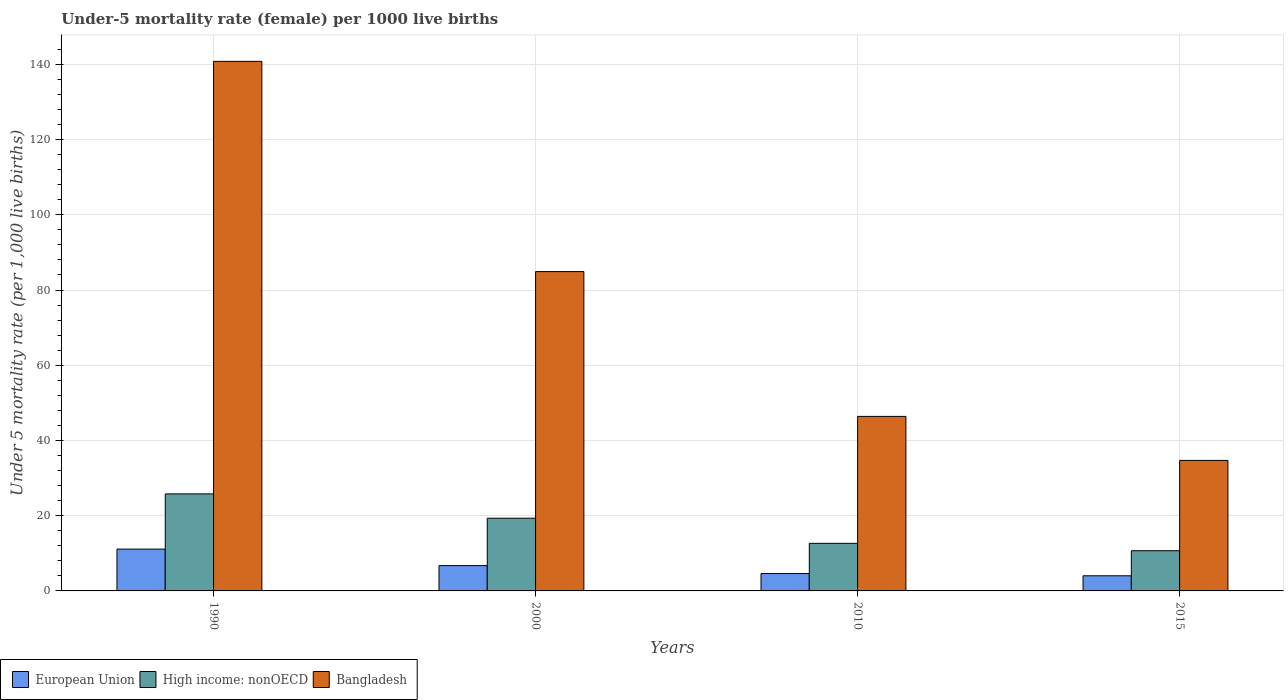Are the number of bars per tick equal to the number of legend labels?
Your answer should be compact. Yes. Are the number of bars on each tick of the X-axis equal?
Ensure brevity in your answer.  Yes. How many bars are there on the 4th tick from the left?
Give a very brief answer. 3. How many bars are there on the 1st tick from the right?
Keep it short and to the point. 3. What is the label of the 4th group of bars from the left?
Keep it short and to the point. 2015. In how many cases, is the number of bars for a given year not equal to the number of legend labels?
Keep it short and to the point. 0. What is the under-five mortality rate in High income: nonOECD in 2010?
Give a very brief answer. 12.65. Across all years, what is the maximum under-five mortality rate in Bangladesh?
Your answer should be compact. 140.8. Across all years, what is the minimum under-five mortality rate in Bangladesh?
Provide a short and direct response. 34.7. In which year was the under-five mortality rate in European Union maximum?
Your answer should be very brief. 1990. In which year was the under-five mortality rate in European Union minimum?
Make the answer very short. 2015. What is the total under-five mortality rate in High income: nonOECD in the graph?
Provide a short and direct response. 68.47. What is the difference between the under-five mortality rate in European Union in 2010 and that in 2015?
Your response must be concise. 0.6. What is the difference between the under-five mortality rate in European Union in 2000 and the under-five mortality rate in Bangladesh in 2015?
Provide a short and direct response. -27.97. What is the average under-five mortality rate in Bangladesh per year?
Provide a short and direct response. 76.7. In the year 2000, what is the difference between the under-five mortality rate in High income: nonOECD and under-five mortality rate in European Union?
Keep it short and to the point. 12.6. In how many years, is the under-five mortality rate in High income: nonOECD greater than 80?
Offer a terse response. 0. What is the ratio of the under-five mortality rate in European Union in 2010 to that in 2015?
Keep it short and to the point. 1.15. What is the difference between the highest and the second highest under-five mortality rate in Bangladesh?
Your answer should be very brief. 55.9. What is the difference between the highest and the lowest under-five mortality rate in European Union?
Provide a short and direct response. 7.1. In how many years, is the under-five mortality rate in High income: nonOECD greater than the average under-five mortality rate in High income: nonOECD taken over all years?
Make the answer very short. 2. Is the sum of the under-five mortality rate in European Union in 1990 and 2015 greater than the maximum under-five mortality rate in High income: nonOECD across all years?
Offer a terse response. No. What does the 2nd bar from the left in 2010 represents?
Offer a very short reply. High income: nonOECD. Is it the case that in every year, the sum of the under-five mortality rate in High income: nonOECD and under-five mortality rate in Bangladesh is greater than the under-five mortality rate in European Union?
Offer a terse response. Yes. How many years are there in the graph?
Ensure brevity in your answer.  4. How many legend labels are there?
Provide a succinct answer. 3. How are the legend labels stacked?
Provide a short and direct response. Horizontal. What is the title of the graph?
Offer a very short reply. Under-5 mortality rate (female) per 1000 live births. Does "Central Europe" appear as one of the legend labels in the graph?
Give a very brief answer. No. What is the label or title of the X-axis?
Offer a very short reply. Years. What is the label or title of the Y-axis?
Offer a terse response. Under 5 mortality rate (per 1,0 live births). What is the Under 5 mortality rate (per 1,000 live births) of European Union in 1990?
Offer a very short reply. 11.12. What is the Under 5 mortality rate (per 1,000 live births) of High income: nonOECD in 1990?
Give a very brief answer. 25.8. What is the Under 5 mortality rate (per 1,000 live births) of Bangladesh in 1990?
Give a very brief answer. 140.8. What is the Under 5 mortality rate (per 1,000 live births) in European Union in 2000?
Your response must be concise. 6.73. What is the Under 5 mortality rate (per 1,000 live births) of High income: nonOECD in 2000?
Offer a very short reply. 19.34. What is the Under 5 mortality rate (per 1,000 live births) in Bangladesh in 2000?
Ensure brevity in your answer.  84.9. What is the Under 5 mortality rate (per 1,000 live births) of European Union in 2010?
Your response must be concise. 4.62. What is the Under 5 mortality rate (per 1,000 live births) in High income: nonOECD in 2010?
Your answer should be very brief. 12.65. What is the Under 5 mortality rate (per 1,000 live births) of Bangladesh in 2010?
Ensure brevity in your answer.  46.4. What is the Under 5 mortality rate (per 1,000 live births) of European Union in 2015?
Ensure brevity in your answer.  4.02. What is the Under 5 mortality rate (per 1,000 live births) in High income: nonOECD in 2015?
Keep it short and to the point. 10.69. What is the Under 5 mortality rate (per 1,000 live births) of Bangladesh in 2015?
Provide a succinct answer. 34.7. Across all years, what is the maximum Under 5 mortality rate (per 1,000 live births) in European Union?
Your answer should be compact. 11.12. Across all years, what is the maximum Under 5 mortality rate (per 1,000 live births) in High income: nonOECD?
Offer a terse response. 25.8. Across all years, what is the maximum Under 5 mortality rate (per 1,000 live births) in Bangladesh?
Your answer should be compact. 140.8. Across all years, what is the minimum Under 5 mortality rate (per 1,000 live births) in European Union?
Keep it short and to the point. 4.02. Across all years, what is the minimum Under 5 mortality rate (per 1,000 live births) in High income: nonOECD?
Provide a succinct answer. 10.69. Across all years, what is the minimum Under 5 mortality rate (per 1,000 live births) of Bangladesh?
Offer a very short reply. 34.7. What is the total Under 5 mortality rate (per 1,000 live births) in European Union in the graph?
Your answer should be very brief. 26.5. What is the total Under 5 mortality rate (per 1,000 live births) in High income: nonOECD in the graph?
Your answer should be very brief. 68.47. What is the total Under 5 mortality rate (per 1,000 live births) in Bangladesh in the graph?
Provide a succinct answer. 306.8. What is the difference between the Under 5 mortality rate (per 1,000 live births) of European Union in 1990 and that in 2000?
Your answer should be compact. 4.38. What is the difference between the Under 5 mortality rate (per 1,000 live births) of High income: nonOECD in 1990 and that in 2000?
Offer a very short reply. 6.46. What is the difference between the Under 5 mortality rate (per 1,000 live births) of Bangladesh in 1990 and that in 2000?
Ensure brevity in your answer.  55.9. What is the difference between the Under 5 mortality rate (per 1,000 live births) of European Union in 1990 and that in 2010?
Your response must be concise. 6.49. What is the difference between the Under 5 mortality rate (per 1,000 live births) of High income: nonOECD in 1990 and that in 2010?
Offer a terse response. 13.15. What is the difference between the Under 5 mortality rate (per 1,000 live births) of Bangladesh in 1990 and that in 2010?
Your answer should be compact. 94.4. What is the difference between the Under 5 mortality rate (per 1,000 live births) in European Union in 1990 and that in 2015?
Ensure brevity in your answer.  7.1. What is the difference between the Under 5 mortality rate (per 1,000 live births) in High income: nonOECD in 1990 and that in 2015?
Give a very brief answer. 15.11. What is the difference between the Under 5 mortality rate (per 1,000 live births) of Bangladesh in 1990 and that in 2015?
Offer a terse response. 106.1. What is the difference between the Under 5 mortality rate (per 1,000 live births) in European Union in 2000 and that in 2010?
Give a very brief answer. 2.11. What is the difference between the Under 5 mortality rate (per 1,000 live births) of High income: nonOECD in 2000 and that in 2010?
Make the answer very short. 6.69. What is the difference between the Under 5 mortality rate (per 1,000 live births) of Bangladesh in 2000 and that in 2010?
Keep it short and to the point. 38.5. What is the difference between the Under 5 mortality rate (per 1,000 live births) of European Union in 2000 and that in 2015?
Offer a very short reply. 2.71. What is the difference between the Under 5 mortality rate (per 1,000 live births) in High income: nonOECD in 2000 and that in 2015?
Your answer should be compact. 8.65. What is the difference between the Under 5 mortality rate (per 1,000 live births) of Bangladesh in 2000 and that in 2015?
Your response must be concise. 50.2. What is the difference between the Under 5 mortality rate (per 1,000 live births) of European Union in 2010 and that in 2015?
Your answer should be very brief. 0.6. What is the difference between the Under 5 mortality rate (per 1,000 live births) of High income: nonOECD in 2010 and that in 2015?
Your answer should be compact. 1.96. What is the difference between the Under 5 mortality rate (per 1,000 live births) of Bangladesh in 2010 and that in 2015?
Your response must be concise. 11.7. What is the difference between the Under 5 mortality rate (per 1,000 live births) of European Union in 1990 and the Under 5 mortality rate (per 1,000 live births) of High income: nonOECD in 2000?
Ensure brevity in your answer.  -8.22. What is the difference between the Under 5 mortality rate (per 1,000 live births) in European Union in 1990 and the Under 5 mortality rate (per 1,000 live births) in Bangladesh in 2000?
Your response must be concise. -73.78. What is the difference between the Under 5 mortality rate (per 1,000 live births) of High income: nonOECD in 1990 and the Under 5 mortality rate (per 1,000 live births) of Bangladesh in 2000?
Offer a very short reply. -59.1. What is the difference between the Under 5 mortality rate (per 1,000 live births) in European Union in 1990 and the Under 5 mortality rate (per 1,000 live births) in High income: nonOECD in 2010?
Keep it short and to the point. -1.53. What is the difference between the Under 5 mortality rate (per 1,000 live births) of European Union in 1990 and the Under 5 mortality rate (per 1,000 live births) of Bangladesh in 2010?
Your answer should be compact. -35.28. What is the difference between the Under 5 mortality rate (per 1,000 live births) in High income: nonOECD in 1990 and the Under 5 mortality rate (per 1,000 live births) in Bangladesh in 2010?
Your answer should be very brief. -20.6. What is the difference between the Under 5 mortality rate (per 1,000 live births) of European Union in 1990 and the Under 5 mortality rate (per 1,000 live births) of High income: nonOECD in 2015?
Your response must be concise. 0.43. What is the difference between the Under 5 mortality rate (per 1,000 live births) in European Union in 1990 and the Under 5 mortality rate (per 1,000 live births) in Bangladesh in 2015?
Offer a terse response. -23.58. What is the difference between the Under 5 mortality rate (per 1,000 live births) of High income: nonOECD in 1990 and the Under 5 mortality rate (per 1,000 live births) of Bangladesh in 2015?
Your response must be concise. -8.9. What is the difference between the Under 5 mortality rate (per 1,000 live births) in European Union in 2000 and the Under 5 mortality rate (per 1,000 live births) in High income: nonOECD in 2010?
Give a very brief answer. -5.92. What is the difference between the Under 5 mortality rate (per 1,000 live births) in European Union in 2000 and the Under 5 mortality rate (per 1,000 live births) in Bangladesh in 2010?
Keep it short and to the point. -39.67. What is the difference between the Under 5 mortality rate (per 1,000 live births) in High income: nonOECD in 2000 and the Under 5 mortality rate (per 1,000 live births) in Bangladesh in 2010?
Keep it short and to the point. -27.06. What is the difference between the Under 5 mortality rate (per 1,000 live births) of European Union in 2000 and the Under 5 mortality rate (per 1,000 live births) of High income: nonOECD in 2015?
Provide a short and direct response. -3.95. What is the difference between the Under 5 mortality rate (per 1,000 live births) in European Union in 2000 and the Under 5 mortality rate (per 1,000 live births) in Bangladesh in 2015?
Keep it short and to the point. -27.97. What is the difference between the Under 5 mortality rate (per 1,000 live births) in High income: nonOECD in 2000 and the Under 5 mortality rate (per 1,000 live births) in Bangladesh in 2015?
Your answer should be compact. -15.36. What is the difference between the Under 5 mortality rate (per 1,000 live births) of European Union in 2010 and the Under 5 mortality rate (per 1,000 live births) of High income: nonOECD in 2015?
Your response must be concise. -6.06. What is the difference between the Under 5 mortality rate (per 1,000 live births) in European Union in 2010 and the Under 5 mortality rate (per 1,000 live births) in Bangladesh in 2015?
Your answer should be compact. -30.08. What is the difference between the Under 5 mortality rate (per 1,000 live births) of High income: nonOECD in 2010 and the Under 5 mortality rate (per 1,000 live births) of Bangladesh in 2015?
Offer a terse response. -22.05. What is the average Under 5 mortality rate (per 1,000 live births) of European Union per year?
Your response must be concise. 6.62. What is the average Under 5 mortality rate (per 1,000 live births) in High income: nonOECD per year?
Offer a very short reply. 17.12. What is the average Under 5 mortality rate (per 1,000 live births) in Bangladesh per year?
Provide a succinct answer. 76.7. In the year 1990, what is the difference between the Under 5 mortality rate (per 1,000 live births) of European Union and Under 5 mortality rate (per 1,000 live births) of High income: nonOECD?
Offer a terse response. -14.68. In the year 1990, what is the difference between the Under 5 mortality rate (per 1,000 live births) of European Union and Under 5 mortality rate (per 1,000 live births) of Bangladesh?
Offer a terse response. -129.68. In the year 1990, what is the difference between the Under 5 mortality rate (per 1,000 live births) of High income: nonOECD and Under 5 mortality rate (per 1,000 live births) of Bangladesh?
Your answer should be very brief. -115. In the year 2000, what is the difference between the Under 5 mortality rate (per 1,000 live births) in European Union and Under 5 mortality rate (per 1,000 live births) in High income: nonOECD?
Ensure brevity in your answer.  -12.6. In the year 2000, what is the difference between the Under 5 mortality rate (per 1,000 live births) in European Union and Under 5 mortality rate (per 1,000 live births) in Bangladesh?
Provide a short and direct response. -78.17. In the year 2000, what is the difference between the Under 5 mortality rate (per 1,000 live births) in High income: nonOECD and Under 5 mortality rate (per 1,000 live births) in Bangladesh?
Provide a succinct answer. -65.56. In the year 2010, what is the difference between the Under 5 mortality rate (per 1,000 live births) of European Union and Under 5 mortality rate (per 1,000 live births) of High income: nonOECD?
Offer a terse response. -8.03. In the year 2010, what is the difference between the Under 5 mortality rate (per 1,000 live births) in European Union and Under 5 mortality rate (per 1,000 live births) in Bangladesh?
Offer a very short reply. -41.78. In the year 2010, what is the difference between the Under 5 mortality rate (per 1,000 live births) in High income: nonOECD and Under 5 mortality rate (per 1,000 live births) in Bangladesh?
Provide a succinct answer. -33.75. In the year 2015, what is the difference between the Under 5 mortality rate (per 1,000 live births) of European Union and Under 5 mortality rate (per 1,000 live births) of High income: nonOECD?
Offer a terse response. -6.66. In the year 2015, what is the difference between the Under 5 mortality rate (per 1,000 live births) of European Union and Under 5 mortality rate (per 1,000 live births) of Bangladesh?
Keep it short and to the point. -30.68. In the year 2015, what is the difference between the Under 5 mortality rate (per 1,000 live births) in High income: nonOECD and Under 5 mortality rate (per 1,000 live births) in Bangladesh?
Offer a very short reply. -24.01. What is the ratio of the Under 5 mortality rate (per 1,000 live births) in European Union in 1990 to that in 2000?
Ensure brevity in your answer.  1.65. What is the ratio of the Under 5 mortality rate (per 1,000 live births) of High income: nonOECD in 1990 to that in 2000?
Offer a terse response. 1.33. What is the ratio of the Under 5 mortality rate (per 1,000 live births) of Bangladesh in 1990 to that in 2000?
Your answer should be compact. 1.66. What is the ratio of the Under 5 mortality rate (per 1,000 live births) in European Union in 1990 to that in 2010?
Provide a short and direct response. 2.4. What is the ratio of the Under 5 mortality rate (per 1,000 live births) of High income: nonOECD in 1990 to that in 2010?
Provide a succinct answer. 2.04. What is the ratio of the Under 5 mortality rate (per 1,000 live births) in Bangladesh in 1990 to that in 2010?
Offer a terse response. 3.03. What is the ratio of the Under 5 mortality rate (per 1,000 live births) of European Union in 1990 to that in 2015?
Your answer should be very brief. 2.76. What is the ratio of the Under 5 mortality rate (per 1,000 live births) in High income: nonOECD in 1990 to that in 2015?
Provide a short and direct response. 2.41. What is the ratio of the Under 5 mortality rate (per 1,000 live births) of Bangladesh in 1990 to that in 2015?
Offer a very short reply. 4.06. What is the ratio of the Under 5 mortality rate (per 1,000 live births) in European Union in 2000 to that in 2010?
Keep it short and to the point. 1.46. What is the ratio of the Under 5 mortality rate (per 1,000 live births) in High income: nonOECD in 2000 to that in 2010?
Provide a short and direct response. 1.53. What is the ratio of the Under 5 mortality rate (per 1,000 live births) in Bangladesh in 2000 to that in 2010?
Provide a succinct answer. 1.83. What is the ratio of the Under 5 mortality rate (per 1,000 live births) in European Union in 2000 to that in 2015?
Your answer should be compact. 1.67. What is the ratio of the Under 5 mortality rate (per 1,000 live births) of High income: nonOECD in 2000 to that in 2015?
Make the answer very short. 1.81. What is the ratio of the Under 5 mortality rate (per 1,000 live births) in Bangladesh in 2000 to that in 2015?
Provide a succinct answer. 2.45. What is the ratio of the Under 5 mortality rate (per 1,000 live births) in European Union in 2010 to that in 2015?
Provide a succinct answer. 1.15. What is the ratio of the Under 5 mortality rate (per 1,000 live births) in High income: nonOECD in 2010 to that in 2015?
Ensure brevity in your answer.  1.18. What is the ratio of the Under 5 mortality rate (per 1,000 live births) in Bangladesh in 2010 to that in 2015?
Ensure brevity in your answer.  1.34. What is the difference between the highest and the second highest Under 5 mortality rate (per 1,000 live births) in European Union?
Give a very brief answer. 4.38. What is the difference between the highest and the second highest Under 5 mortality rate (per 1,000 live births) of High income: nonOECD?
Provide a short and direct response. 6.46. What is the difference between the highest and the second highest Under 5 mortality rate (per 1,000 live births) in Bangladesh?
Make the answer very short. 55.9. What is the difference between the highest and the lowest Under 5 mortality rate (per 1,000 live births) of European Union?
Provide a short and direct response. 7.1. What is the difference between the highest and the lowest Under 5 mortality rate (per 1,000 live births) of High income: nonOECD?
Your answer should be very brief. 15.11. What is the difference between the highest and the lowest Under 5 mortality rate (per 1,000 live births) in Bangladesh?
Make the answer very short. 106.1. 